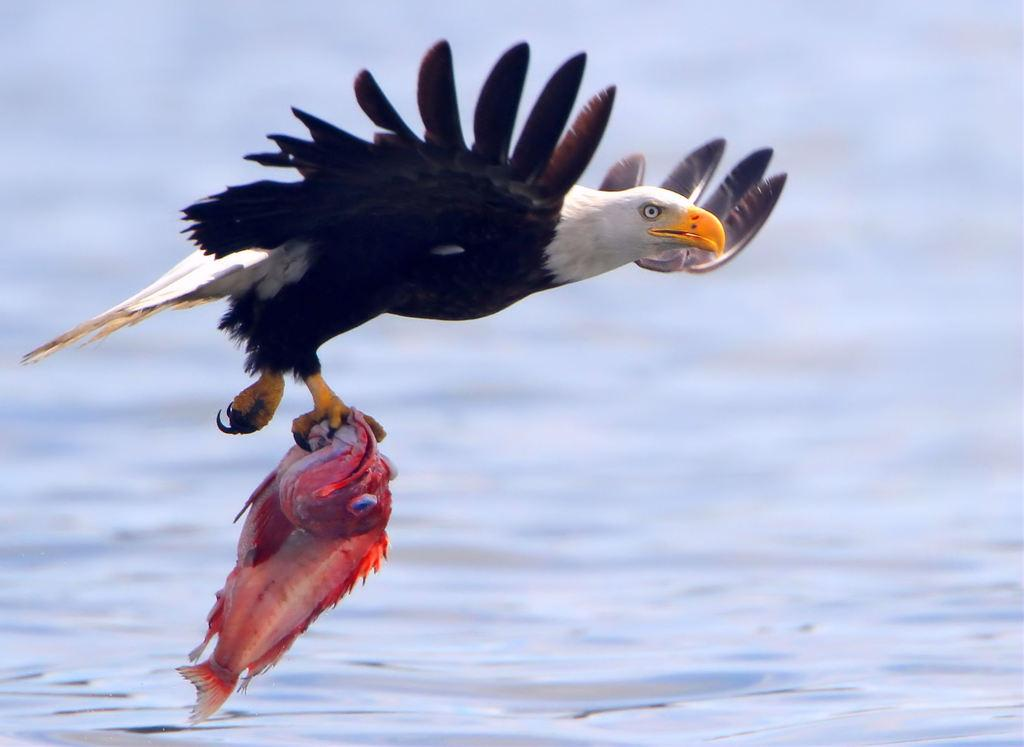What type of animal is in the image? There is a bird in the image. What is the bird doing in the image? The bird is holding food. Can you describe the background of the image? The background of the image is blurry. How does the bird maintain its balance while holding the food and being part of a team in the image? There is no indication in the image that the bird is part of a team or needs to maintain balance while holding the food. 